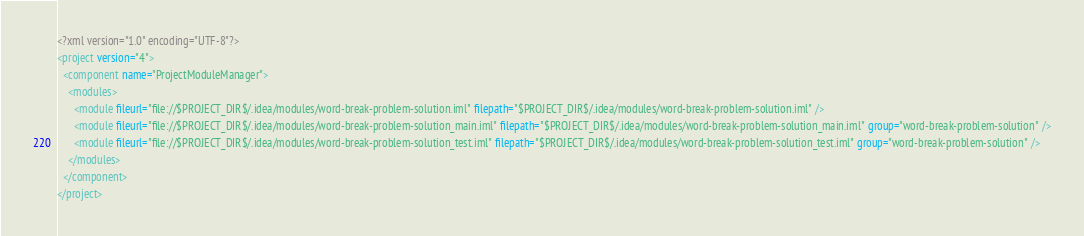Convert code to text. <code><loc_0><loc_0><loc_500><loc_500><_XML_><?xml version="1.0" encoding="UTF-8"?>
<project version="4">
  <component name="ProjectModuleManager">
    <modules>
      <module fileurl="file://$PROJECT_DIR$/.idea/modules/word-break-problem-solution.iml" filepath="$PROJECT_DIR$/.idea/modules/word-break-problem-solution.iml" />
      <module fileurl="file://$PROJECT_DIR$/.idea/modules/word-break-problem-solution_main.iml" filepath="$PROJECT_DIR$/.idea/modules/word-break-problem-solution_main.iml" group="word-break-problem-solution" />
      <module fileurl="file://$PROJECT_DIR$/.idea/modules/word-break-problem-solution_test.iml" filepath="$PROJECT_DIR$/.idea/modules/word-break-problem-solution_test.iml" group="word-break-problem-solution" />
    </modules>
  </component>
</project></code> 